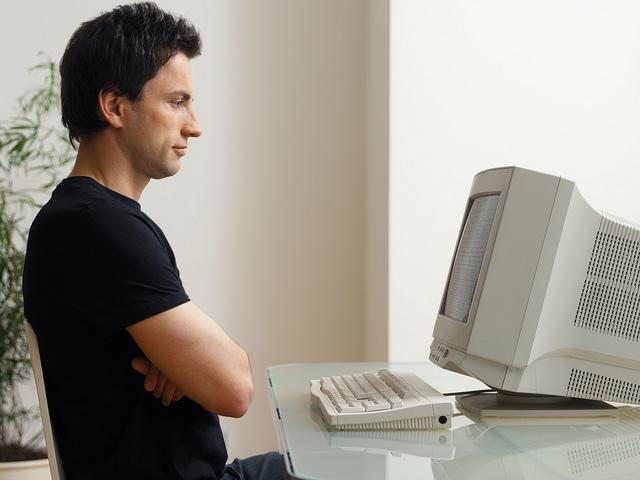How many keyboards are there?
Give a very brief answer. 1. How many vases are above the fireplace?
Give a very brief answer. 0. 